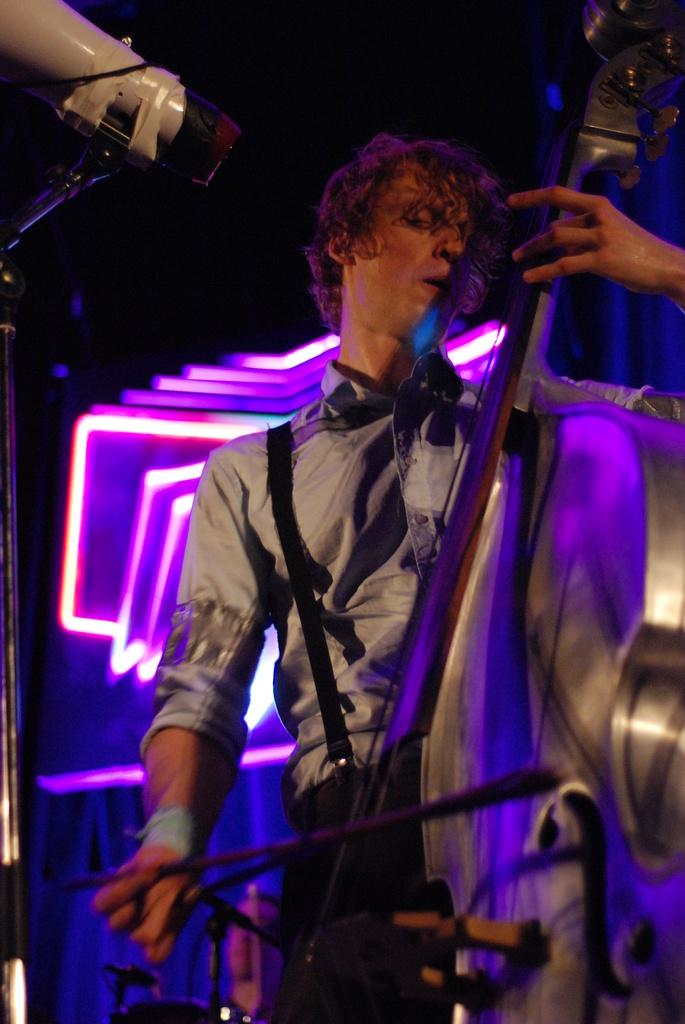What is the main subject of the image? There is a person in the image. What is the person doing in the image? The person is playing a violin. Can you describe the person's clothing in the image? The person is wearing a shirt and suspenders. What can be seen behind the person in the image? There are lights visible behind the person. What is the person's opinion on the distribution of stem cells in the image? There is no mention of stem cells or any related opinions in the image. 